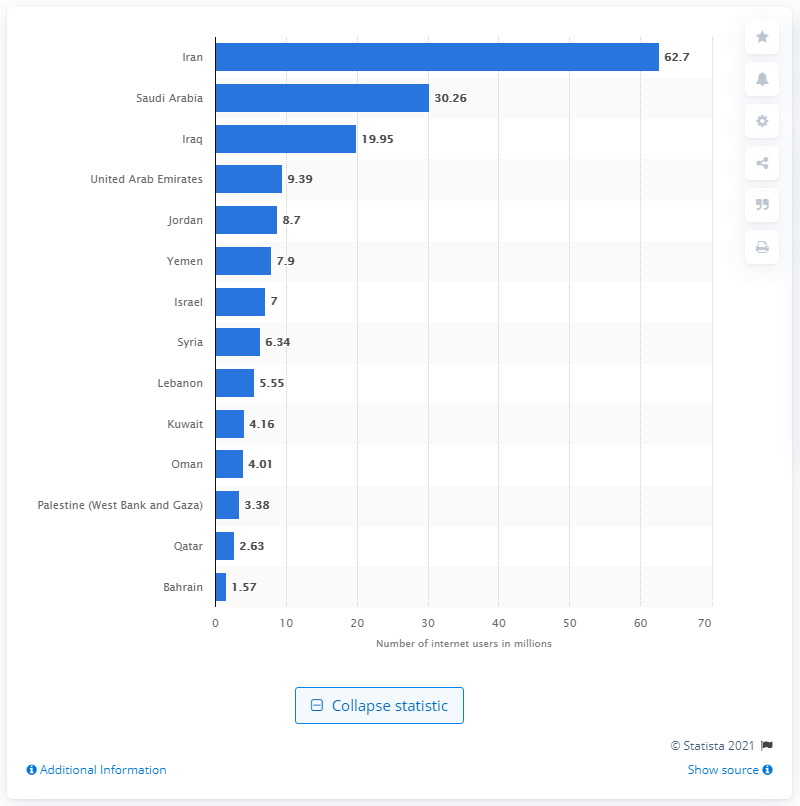Draw attention to some important aspects in this diagram. As of April 2019, the number of internet users in Iran was 62.7 million. According to data from April 2019, Saudi Arabia had the highest number of internet users among all countries. 